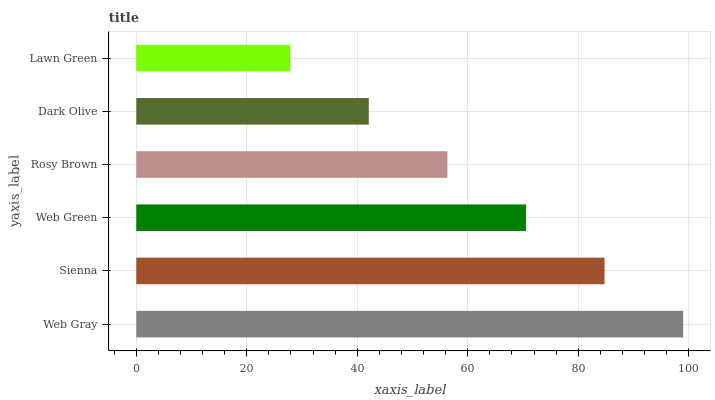Is Lawn Green the minimum?
Answer yes or no. Yes. Is Web Gray the maximum?
Answer yes or no. Yes. Is Sienna the minimum?
Answer yes or no. No. Is Sienna the maximum?
Answer yes or no. No. Is Web Gray greater than Sienna?
Answer yes or no. Yes. Is Sienna less than Web Gray?
Answer yes or no. Yes. Is Sienna greater than Web Gray?
Answer yes or no. No. Is Web Gray less than Sienna?
Answer yes or no. No. Is Web Green the high median?
Answer yes or no. Yes. Is Rosy Brown the low median?
Answer yes or no. Yes. Is Rosy Brown the high median?
Answer yes or no. No. Is Web Green the low median?
Answer yes or no. No. 